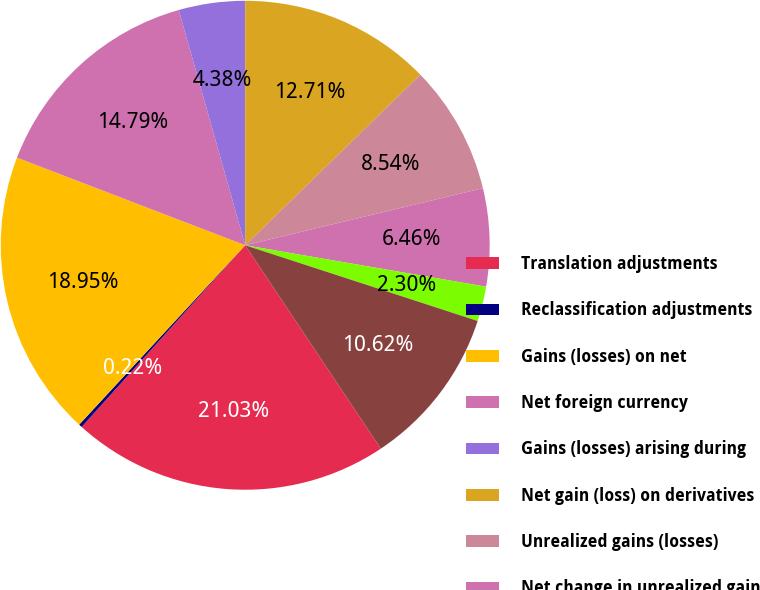Convert chart. <chart><loc_0><loc_0><loc_500><loc_500><pie_chart><fcel>Translation adjustments<fcel>Reclassification adjustments<fcel>Gains (losses) on net<fcel>Net foreign currency<fcel>Gains (losses) arising during<fcel>Net gain (loss) on derivatives<fcel>Unrealized gains (losses)<fcel>Net change in unrealized gain<fcel>Net pension and other benefits<fcel>Net change in pension and<nl><fcel>21.02%<fcel>0.22%<fcel>18.94%<fcel>14.78%<fcel>4.38%<fcel>12.7%<fcel>8.54%<fcel>6.46%<fcel>2.3%<fcel>10.62%<nl></chart> 